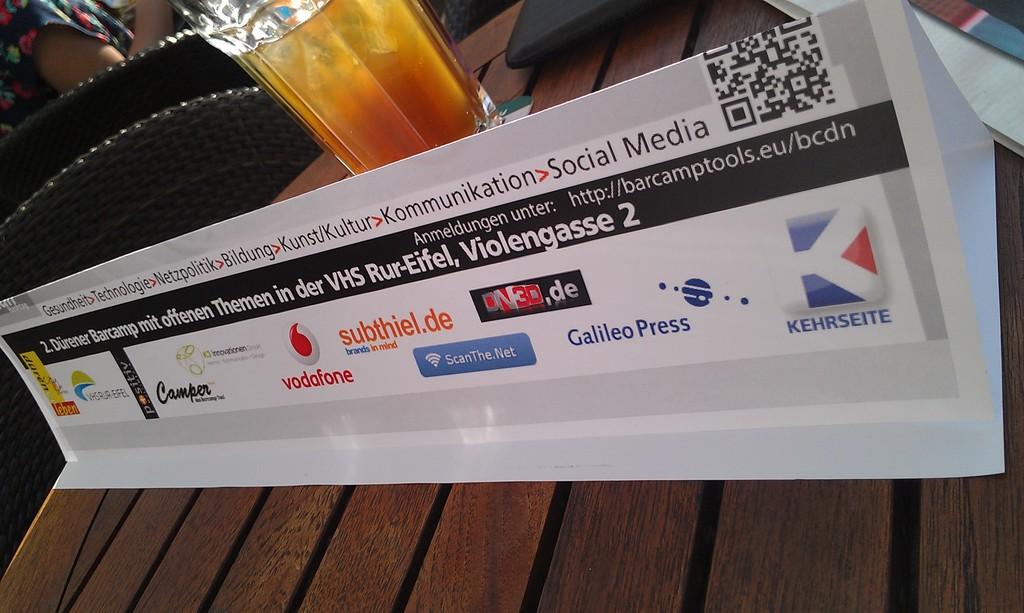What is the major cellular phone carrier shown?
Make the answer very short. Vodafone. What is the right sponsor?
Your answer should be very brief. Kehrseite. 